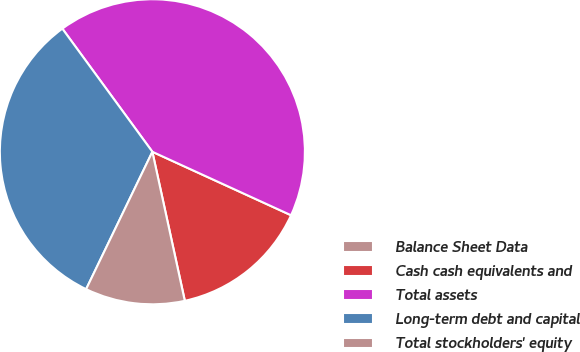Convert chart to OTSL. <chart><loc_0><loc_0><loc_500><loc_500><pie_chart><fcel>Balance Sheet Data<fcel>Cash cash equivalents and<fcel>Total assets<fcel>Long-term debt and capital<fcel>Total stockholders' equity<nl><fcel>0.01%<fcel>14.75%<fcel>41.88%<fcel>32.8%<fcel>10.56%<nl></chart> 